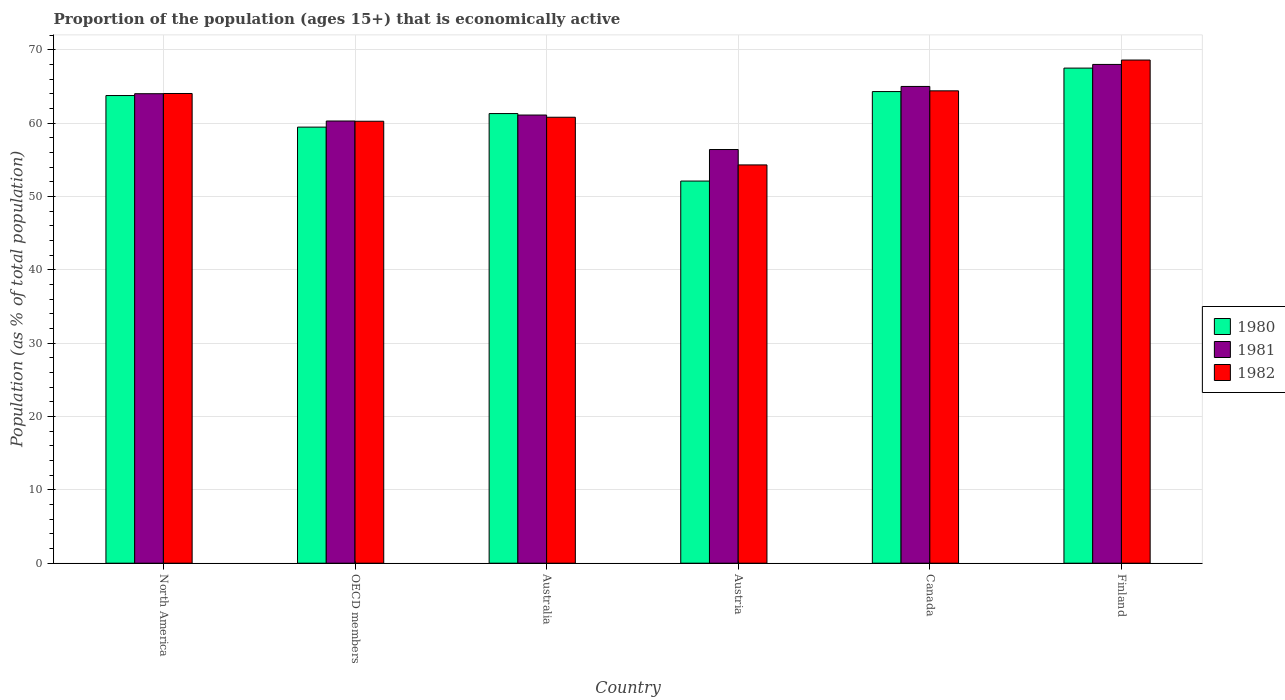How many groups of bars are there?
Keep it short and to the point. 6. In how many cases, is the number of bars for a given country not equal to the number of legend labels?
Your answer should be compact. 0. What is the proportion of the population that is economically active in 1981 in Austria?
Make the answer very short. 56.4. Across all countries, what is the maximum proportion of the population that is economically active in 1982?
Give a very brief answer. 68.6. Across all countries, what is the minimum proportion of the population that is economically active in 1982?
Make the answer very short. 54.3. In which country was the proportion of the population that is economically active in 1981 maximum?
Ensure brevity in your answer.  Finland. What is the total proportion of the population that is economically active in 1981 in the graph?
Offer a terse response. 374.79. What is the difference between the proportion of the population that is economically active in 1980 in Canada and that in North America?
Provide a succinct answer. 0.54. What is the difference between the proportion of the population that is economically active in 1981 in Canada and the proportion of the population that is economically active in 1982 in Finland?
Offer a terse response. -3.6. What is the average proportion of the population that is economically active in 1982 per country?
Your answer should be very brief. 62.07. What is the difference between the proportion of the population that is economically active of/in 1981 and proportion of the population that is economically active of/in 1980 in Australia?
Your answer should be compact. -0.2. In how many countries, is the proportion of the population that is economically active in 1981 greater than 42 %?
Make the answer very short. 6. What is the ratio of the proportion of the population that is economically active in 1980 in Australia to that in North America?
Provide a succinct answer. 0.96. Is the difference between the proportion of the population that is economically active in 1981 in Australia and Canada greater than the difference between the proportion of the population that is economically active in 1980 in Australia and Canada?
Ensure brevity in your answer.  No. What is the difference between the highest and the second highest proportion of the population that is economically active in 1981?
Your response must be concise. -0.99. What is the difference between the highest and the lowest proportion of the population that is economically active in 1980?
Your answer should be compact. 15.4. What does the 3rd bar from the right in Canada represents?
Give a very brief answer. 1980. Is it the case that in every country, the sum of the proportion of the population that is economically active in 1982 and proportion of the population that is economically active in 1981 is greater than the proportion of the population that is economically active in 1980?
Your answer should be very brief. Yes. Are all the bars in the graph horizontal?
Give a very brief answer. No. Does the graph contain any zero values?
Your response must be concise. No. What is the title of the graph?
Give a very brief answer. Proportion of the population (ages 15+) that is economically active. What is the label or title of the Y-axis?
Your answer should be compact. Population (as % of total population). What is the Population (as % of total population) of 1980 in North America?
Offer a very short reply. 63.76. What is the Population (as % of total population) in 1981 in North America?
Keep it short and to the point. 64.01. What is the Population (as % of total population) of 1982 in North America?
Offer a terse response. 64.04. What is the Population (as % of total population) in 1980 in OECD members?
Ensure brevity in your answer.  59.45. What is the Population (as % of total population) of 1981 in OECD members?
Your answer should be compact. 60.29. What is the Population (as % of total population) in 1982 in OECD members?
Provide a short and direct response. 60.25. What is the Population (as % of total population) of 1980 in Australia?
Your answer should be compact. 61.3. What is the Population (as % of total population) of 1981 in Australia?
Your answer should be very brief. 61.1. What is the Population (as % of total population) of 1982 in Australia?
Offer a terse response. 60.8. What is the Population (as % of total population) of 1980 in Austria?
Ensure brevity in your answer.  52.1. What is the Population (as % of total population) of 1981 in Austria?
Your answer should be compact. 56.4. What is the Population (as % of total population) of 1982 in Austria?
Provide a short and direct response. 54.3. What is the Population (as % of total population) in 1980 in Canada?
Keep it short and to the point. 64.3. What is the Population (as % of total population) in 1981 in Canada?
Your answer should be very brief. 65. What is the Population (as % of total population) in 1982 in Canada?
Ensure brevity in your answer.  64.4. What is the Population (as % of total population) of 1980 in Finland?
Your answer should be very brief. 67.5. What is the Population (as % of total population) of 1982 in Finland?
Keep it short and to the point. 68.6. Across all countries, what is the maximum Population (as % of total population) in 1980?
Provide a short and direct response. 67.5. Across all countries, what is the maximum Population (as % of total population) of 1981?
Provide a succinct answer. 68. Across all countries, what is the maximum Population (as % of total population) in 1982?
Your answer should be compact. 68.6. Across all countries, what is the minimum Population (as % of total population) in 1980?
Your answer should be very brief. 52.1. Across all countries, what is the minimum Population (as % of total population) in 1981?
Offer a very short reply. 56.4. Across all countries, what is the minimum Population (as % of total population) in 1982?
Ensure brevity in your answer.  54.3. What is the total Population (as % of total population) in 1980 in the graph?
Provide a succinct answer. 368.41. What is the total Population (as % of total population) of 1981 in the graph?
Your answer should be compact. 374.79. What is the total Population (as % of total population) in 1982 in the graph?
Ensure brevity in your answer.  372.39. What is the difference between the Population (as % of total population) of 1980 in North America and that in OECD members?
Your answer should be compact. 4.3. What is the difference between the Population (as % of total population) in 1981 in North America and that in OECD members?
Keep it short and to the point. 3.72. What is the difference between the Population (as % of total population) in 1982 in North America and that in OECD members?
Provide a succinct answer. 3.78. What is the difference between the Population (as % of total population) of 1980 in North America and that in Australia?
Offer a terse response. 2.46. What is the difference between the Population (as % of total population) of 1981 in North America and that in Australia?
Ensure brevity in your answer.  2.91. What is the difference between the Population (as % of total population) of 1982 in North America and that in Australia?
Keep it short and to the point. 3.24. What is the difference between the Population (as % of total population) of 1980 in North America and that in Austria?
Keep it short and to the point. 11.66. What is the difference between the Population (as % of total population) in 1981 in North America and that in Austria?
Keep it short and to the point. 7.61. What is the difference between the Population (as % of total population) of 1982 in North America and that in Austria?
Provide a succinct answer. 9.74. What is the difference between the Population (as % of total population) in 1980 in North America and that in Canada?
Provide a short and direct response. -0.54. What is the difference between the Population (as % of total population) in 1981 in North America and that in Canada?
Provide a short and direct response. -0.99. What is the difference between the Population (as % of total population) in 1982 in North America and that in Canada?
Provide a succinct answer. -0.36. What is the difference between the Population (as % of total population) in 1980 in North America and that in Finland?
Keep it short and to the point. -3.74. What is the difference between the Population (as % of total population) in 1981 in North America and that in Finland?
Your response must be concise. -3.99. What is the difference between the Population (as % of total population) in 1982 in North America and that in Finland?
Provide a succinct answer. -4.56. What is the difference between the Population (as % of total population) of 1980 in OECD members and that in Australia?
Ensure brevity in your answer.  -1.85. What is the difference between the Population (as % of total population) in 1981 in OECD members and that in Australia?
Your response must be concise. -0.81. What is the difference between the Population (as % of total population) in 1982 in OECD members and that in Australia?
Provide a short and direct response. -0.55. What is the difference between the Population (as % of total population) of 1980 in OECD members and that in Austria?
Your response must be concise. 7.35. What is the difference between the Population (as % of total population) in 1981 in OECD members and that in Austria?
Your response must be concise. 3.89. What is the difference between the Population (as % of total population) in 1982 in OECD members and that in Austria?
Provide a short and direct response. 5.95. What is the difference between the Population (as % of total population) in 1980 in OECD members and that in Canada?
Your answer should be compact. -4.85. What is the difference between the Population (as % of total population) of 1981 in OECD members and that in Canada?
Offer a very short reply. -4.71. What is the difference between the Population (as % of total population) of 1982 in OECD members and that in Canada?
Your answer should be very brief. -4.15. What is the difference between the Population (as % of total population) of 1980 in OECD members and that in Finland?
Your response must be concise. -8.05. What is the difference between the Population (as % of total population) of 1981 in OECD members and that in Finland?
Make the answer very short. -7.71. What is the difference between the Population (as % of total population) in 1982 in OECD members and that in Finland?
Your answer should be compact. -8.35. What is the difference between the Population (as % of total population) in 1980 in Australia and that in Austria?
Keep it short and to the point. 9.2. What is the difference between the Population (as % of total population) in 1981 in Australia and that in Austria?
Your answer should be compact. 4.7. What is the difference between the Population (as % of total population) of 1980 in Australia and that in Canada?
Offer a very short reply. -3. What is the difference between the Population (as % of total population) in 1980 in Australia and that in Finland?
Provide a short and direct response. -6.2. What is the difference between the Population (as % of total population) of 1981 in Australia and that in Finland?
Your answer should be compact. -6.9. What is the difference between the Population (as % of total population) in 1981 in Austria and that in Canada?
Offer a terse response. -8.6. What is the difference between the Population (as % of total population) of 1982 in Austria and that in Canada?
Ensure brevity in your answer.  -10.1. What is the difference between the Population (as % of total population) in 1980 in Austria and that in Finland?
Offer a very short reply. -15.4. What is the difference between the Population (as % of total population) of 1981 in Austria and that in Finland?
Provide a succinct answer. -11.6. What is the difference between the Population (as % of total population) in 1982 in Austria and that in Finland?
Provide a short and direct response. -14.3. What is the difference between the Population (as % of total population) in 1980 in Canada and that in Finland?
Keep it short and to the point. -3.2. What is the difference between the Population (as % of total population) in 1982 in Canada and that in Finland?
Provide a short and direct response. -4.2. What is the difference between the Population (as % of total population) in 1980 in North America and the Population (as % of total population) in 1981 in OECD members?
Your answer should be compact. 3.47. What is the difference between the Population (as % of total population) of 1980 in North America and the Population (as % of total population) of 1982 in OECD members?
Your answer should be compact. 3.5. What is the difference between the Population (as % of total population) of 1981 in North America and the Population (as % of total population) of 1982 in OECD members?
Offer a terse response. 3.75. What is the difference between the Population (as % of total population) of 1980 in North America and the Population (as % of total population) of 1981 in Australia?
Give a very brief answer. 2.66. What is the difference between the Population (as % of total population) of 1980 in North America and the Population (as % of total population) of 1982 in Australia?
Give a very brief answer. 2.96. What is the difference between the Population (as % of total population) in 1981 in North America and the Population (as % of total population) in 1982 in Australia?
Your response must be concise. 3.21. What is the difference between the Population (as % of total population) of 1980 in North America and the Population (as % of total population) of 1981 in Austria?
Your answer should be very brief. 7.36. What is the difference between the Population (as % of total population) of 1980 in North America and the Population (as % of total population) of 1982 in Austria?
Keep it short and to the point. 9.46. What is the difference between the Population (as % of total population) of 1981 in North America and the Population (as % of total population) of 1982 in Austria?
Offer a very short reply. 9.71. What is the difference between the Population (as % of total population) in 1980 in North America and the Population (as % of total population) in 1981 in Canada?
Give a very brief answer. -1.24. What is the difference between the Population (as % of total population) in 1980 in North America and the Population (as % of total population) in 1982 in Canada?
Offer a terse response. -0.64. What is the difference between the Population (as % of total population) in 1981 in North America and the Population (as % of total population) in 1982 in Canada?
Offer a very short reply. -0.39. What is the difference between the Population (as % of total population) of 1980 in North America and the Population (as % of total population) of 1981 in Finland?
Your answer should be very brief. -4.24. What is the difference between the Population (as % of total population) of 1980 in North America and the Population (as % of total population) of 1982 in Finland?
Give a very brief answer. -4.84. What is the difference between the Population (as % of total population) in 1981 in North America and the Population (as % of total population) in 1982 in Finland?
Provide a succinct answer. -4.59. What is the difference between the Population (as % of total population) of 1980 in OECD members and the Population (as % of total population) of 1981 in Australia?
Give a very brief answer. -1.65. What is the difference between the Population (as % of total population) of 1980 in OECD members and the Population (as % of total population) of 1982 in Australia?
Ensure brevity in your answer.  -1.35. What is the difference between the Population (as % of total population) of 1981 in OECD members and the Population (as % of total population) of 1982 in Australia?
Offer a very short reply. -0.51. What is the difference between the Population (as % of total population) in 1980 in OECD members and the Population (as % of total population) in 1981 in Austria?
Your answer should be very brief. 3.05. What is the difference between the Population (as % of total population) of 1980 in OECD members and the Population (as % of total population) of 1982 in Austria?
Provide a short and direct response. 5.15. What is the difference between the Population (as % of total population) of 1981 in OECD members and the Population (as % of total population) of 1982 in Austria?
Offer a very short reply. 5.99. What is the difference between the Population (as % of total population) in 1980 in OECD members and the Population (as % of total population) in 1981 in Canada?
Your answer should be very brief. -5.55. What is the difference between the Population (as % of total population) of 1980 in OECD members and the Population (as % of total population) of 1982 in Canada?
Keep it short and to the point. -4.95. What is the difference between the Population (as % of total population) of 1981 in OECD members and the Population (as % of total population) of 1982 in Canada?
Ensure brevity in your answer.  -4.11. What is the difference between the Population (as % of total population) in 1980 in OECD members and the Population (as % of total population) in 1981 in Finland?
Your response must be concise. -8.55. What is the difference between the Population (as % of total population) of 1980 in OECD members and the Population (as % of total population) of 1982 in Finland?
Offer a terse response. -9.15. What is the difference between the Population (as % of total population) of 1981 in OECD members and the Population (as % of total population) of 1982 in Finland?
Make the answer very short. -8.31. What is the difference between the Population (as % of total population) of 1980 in Australia and the Population (as % of total population) of 1981 in Canada?
Provide a succinct answer. -3.7. What is the difference between the Population (as % of total population) in 1980 in Australia and the Population (as % of total population) in 1982 in Canada?
Offer a very short reply. -3.1. What is the difference between the Population (as % of total population) of 1981 in Australia and the Population (as % of total population) of 1982 in Canada?
Offer a terse response. -3.3. What is the difference between the Population (as % of total population) of 1980 in Australia and the Population (as % of total population) of 1981 in Finland?
Ensure brevity in your answer.  -6.7. What is the difference between the Population (as % of total population) of 1980 in Australia and the Population (as % of total population) of 1982 in Finland?
Provide a succinct answer. -7.3. What is the difference between the Population (as % of total population) of 1981 in Austria and the Population (as % of total population) of 1982 in Canada?
Make the answer very short. -8. What is the difference between the Population (as % of total population) of 1980 in Austria and the Population (as % of total population) of 1981 in Finland?
Provide a short and direct response. -15.9. What is the difference between the Population (as % of total population) in 1980 in Austria and the Population (as % of total population) in 1982 in Finland?
Give a very brief answer. -16.5. What is the difference between the Population (as % of total population) in 1981 in Canada and the Population (as % of total population) in 1982 in Finland?
Ensure brevity in your answer.  -3.6. What is the average Population (as % of total population) of 1980 per country?
Offer a very short reply. 61.4. What is the average Population (as % of total population) in 1981 per country?
Your answer should be compact. 62.47. What is the average Population (as % of total population) in 1982 per country?
Your answer should be compact. 62.07. What is the difference between the Population (as % of total population) in 1980 and Population (as % of total population) in 1981 in North America?
Keep it short and to the point. -0.25. What is the difference between the Population (as % of total population) in 1980 and Population (as % of total population) in 1982 in North America?
Your response must be concise. -0.28. What is the difference between the Population (as % of total population) in 1981 and Population (as % of total population) in 1982 in North America?
Provide a succinct answer. -0.03. What is the difference between the Population (as % of total population) in 1980 and Population (as % of total population) in 1981 in OECD members?
Provide a short and direct response. -0.83. What is the difference between the Population (as % of total population) in 1980 and Population (as % of total population) in 1982 in OECD members?
Keep it short and to the point. -0.8. What is the difference between the Population (as % of total population) of 1981 and Population (as % of total population) of 1982 in OECD members?
Your answer should be very brief. 0.03. What is the difference between the Population (as % of total population) in 1981 and Population (as % of total population) in 1982 in Australia?
Your answer should be very brief. 0.3. What is the difference between the Population (as % of total population) in 1980 and Population (as % of total population) in 1982 in Austria?
Your response must be concise. -2.2. What is the difference between the Population (as % of total population) in 1981 and Population (as % of total population) in 1982 in Austria?
Offer a terse response. 2.1. What is the difference between the Population (as % of total population) of 1980 and Population (as % of total population) of 1981 in Canada?
Offer a very short reply. -0.7. What is the difference between the Population (as % of total population) in 1981 and Population (as % of total population) in 1982 in Canada?
Your response must be concise. 0.6. What is the difference between the Population (as % of total population) of 1980 and Population (as % of total population) of 1982 in Finland?
Your answer should be compact. -1.1. What is the difference between the Population (as % of total population) in 1981 and Population (as % of total population) in 1982 in Finland?
Offer a terse response. -0.6. What is the ratio of the Population (as % of total population) of 1980 in North America to that in OECD members?
Your answer should be compact. 1.07. What is the ratio of the Population (as % of total population) in 1981 in North America to that in OECD members?
Give a very brief answer. 1.06. What is the ratio of the Population (as % of total population) of 1982 in North America to that in OECD members?
Offer a terse response. 1.06. What is the ratio of the Population (as % of total population) in 1980 in North America to that in Australia?
Make the answer very short. 1.04. What is the ratio of the Population (as % of total population) of 1981 in North America to that in Australia?
Your answer should be compact. 1.05. What is the ratio of the Population (as % of total population) of 1982 in North America to that in Australia?
Keep it short and to the point. 1.05. What is the ratio of the Population (as % of total population) of 1980 in North America to that in Austria?
Ensure brevity in your answer.  1.22. What is the ratio of the Population (as % of total population) in 1981 in North America to that in Austria?
Provide a succinct answer. 1.13. What is the ratio of the Population (as % of total population) of 1982 in North America to that in Austria?
Your response must be concise. 1.18. What is the ratio of the Population (as % of total population) in 1980 in North America to that in Canada?
Your answer should be very brief. 0.99. What is the ratio of the Population (as % of total population) in 1981 in North America to that in Canada?
Your response must be concise. 0.98. What is the ratio of the Population (as % of total population) in 1980 in North America to that in Finland?
Provide a short and direct response. 0.94. What is the ratio of the Population (as % of total population) of 1981 in North America to that in Finland?
Your answer should be very brief. 0.94. What is the ratio of the Population (as % of total population) in 1982 in North America to that in Finland?
Ensure brevity in your answer.  0.93. What is the ratio of the Population (as % of total population) of 1980 in OECD members to that in Australia?
Your response must be concise. 0.97. What is the ratio of the Population (as % of total population) of 1981 in OECD members to that in Australia?
Offer a terse response. 0.99. What is the ratio of the Population (as % of total population) in 1980 in OECD members to that in Austria?
Your answer should be very brief. 1.14. What is the ratio of the Population (as % of total population) in 1981 in OECD members to that in Austria?
Your response must be concise. 1.07. What is the ratio of the Population (as % of total population) in 1982 in OECD members to that in Austria?
Offer a very short reply. 1.11. What is the ratio of the Population (as % of total population) in 1980 in OECD members to that in Canada?
Give a very brief answer. 0.92. What is the ratio of the Population (as % of total population) of 1981 in OECD members to that in Canada?
Your answer should be very brief. 0.93. What is the ratio of the Population (as % of total population) of 1982 in OECD members to that in Canada?
Give a very brief answer. 0.94. What is the ratio of the Population (as % of total population) of 1980 in OECD members to that in Finland?
Provide a short and direct response. 0.88. What is the ratio of the Population (as % of total population) of 1981 in OECD members to that in Finland?
Keep it short and to the point. 0.89. What is the ratio of the Population (as % of total population) of 1982 in OECD members to that in Finland?
Ensure brevity in your answer.  0.88. What is the ratio of the Population (as % of total population) of 1980 in Australia to that in Austria?
Ensure brevity in your answer.  1.18. What is the ratio of the Population (as % of total population) in 1982 in Australia to that in Austria?
Provide a succinct answer. 1.12. What is the ratio of the Population (as % of total population) of 1980 in Australia to that in Canada?
Your answer should be very brief. 0.95. What is the ratio of the Population (as % of total population) of 1982 in Australia to that in Canada?
Offer a very short reply. 0.94. What is the ratio of the Population (as % of total population) of 1980 in Australia to that in Finland?
Your response must be concise. 0.91. What is the ratio of the Population (as % of total population) in 1981 in Australia to that in Finland?
Offer a very short reply. 0.9. What is the ratio of the Population (as % of total population) of 1982 in Australia to that in Finland?
Your answer should be very brief. 0.89. What is the ratio of the Population (as % of total population) in 1980 in Austria to that in Canada?
Offer a very short reply. 0.81. What is the ratio of the Population (as % of total population) of 1981 in Austria to that in Canada?
Your response must be concise. 0.87. What is the ratio of the Population (as % of total population) of 1982 in Austria to that in Canada?
Your response must be concise. 0.84. What is the ratio of the Population (as % of total population) in 1980 in Austria to that in Finland?
Offer a very short reply. 0.77. What is the ratio of the Population (as % of total population) in 1981 in Austria to that in Finland?
Make the answer very short. 0.83. What is the ratio of the Population (as % of total population) of 1982 in Austria to that in Finland?
Ensure brevity in your answer.  0.79. What is the ratio of the Population (as % of total population) in 1980 in Canada to that in Finland?
Offer a terse response. 0.95. What is the ratio of the Population (as % of total population) in 1981 in Canada to that in Finland?
Your answer should be compact. 0.96. What is the ratio of the Population (as % of total population) in 1982 in Canada to that in Finland?
Offer a very short reply. 0.94. What is the difference between the highest and the lowest Population (as % of total population) in 1980?
Give a very brief answer. 15.4. What is the difference between the highest and the lowest Population (as % of total population) of 1981?
Your answer should be very brief. 11.6. 